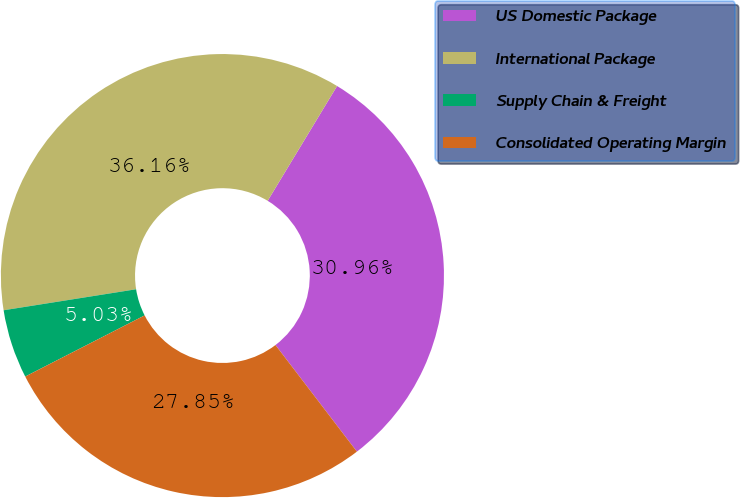Convert chart to OTSL. <chart><loc_0><loc_0><loc_500><loc_500><pie_chart><fcel>US Domestic Package<fcel>International Package<fcel>Supply Chain & Freight<fcel>Consolidated Operating Margin<nl><fcel>30.96%<fcel>36.16%<fcel>5.03%<fcel>27.85%<nl></chart> 